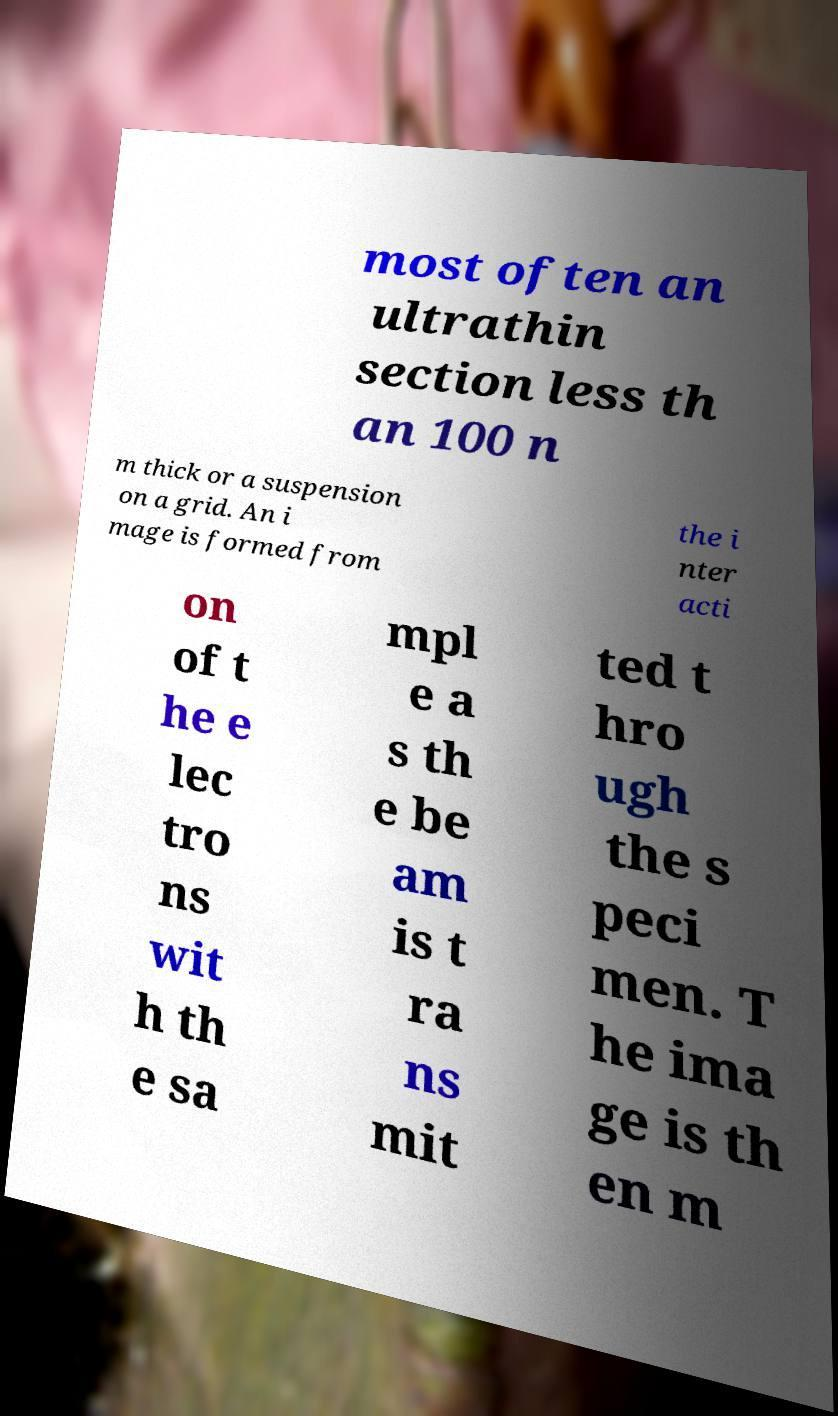Could you assist in decoding the text presented in this image and type it out clearly? most often an ultrathin section less th an 100 n m thick or a suspension on a grid. An i mage is formed from the i nter acti on of t he e lec tro ns wit h th e sa mpl e a s th e be am is t ra ns mit ted t hro ugh the s peci men. T he ima ge is th en m 